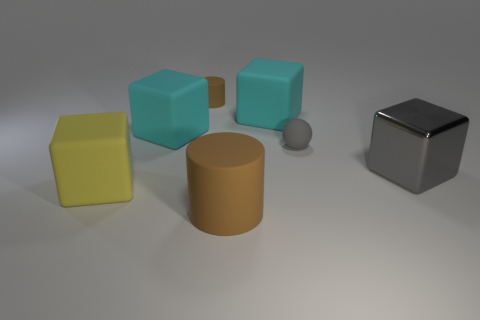There is a big gray metal object; is it the same shape as the brown rubber object that is to the right of the small rubber cylinder?
Provide a short and direct response. No. How many cyan objects have the same size as the gray matte thing?
Offer a very short reply. 0. What material is the other object that is the same shape as the tiny brown matte object?
Provide a succinct answer. Rubber. There is a big matte cylinder that is on the left side of the large gray object; is it the same color as the rubber cylinder that is behind the big gray metal block?
Ensure brevity in your answer.  Yes. What is the shape of the small object that is on the right side of the small cylinder?
Keep it short and to the point. Sphere. The big metallic block has what color?
Your answer should be compact. Gray. The large brown object that is made of the same material as the yellow block is what shape?
Provide a succinct answer. Cylinder. Is the size of the brown matte thing that is in front of the gray cube the same as the gray ball?
Ensure brevity in your answer.  No. How many things are brown matte cylinders that are in front of the large yellow matte thing or brown things that are behind the small gray rubber thing?
Provide a succinct answer. 2. Is the color of the small thing that is to the right of the big brown thing the same as the metal object?
Offer a very short reply. Yes. 